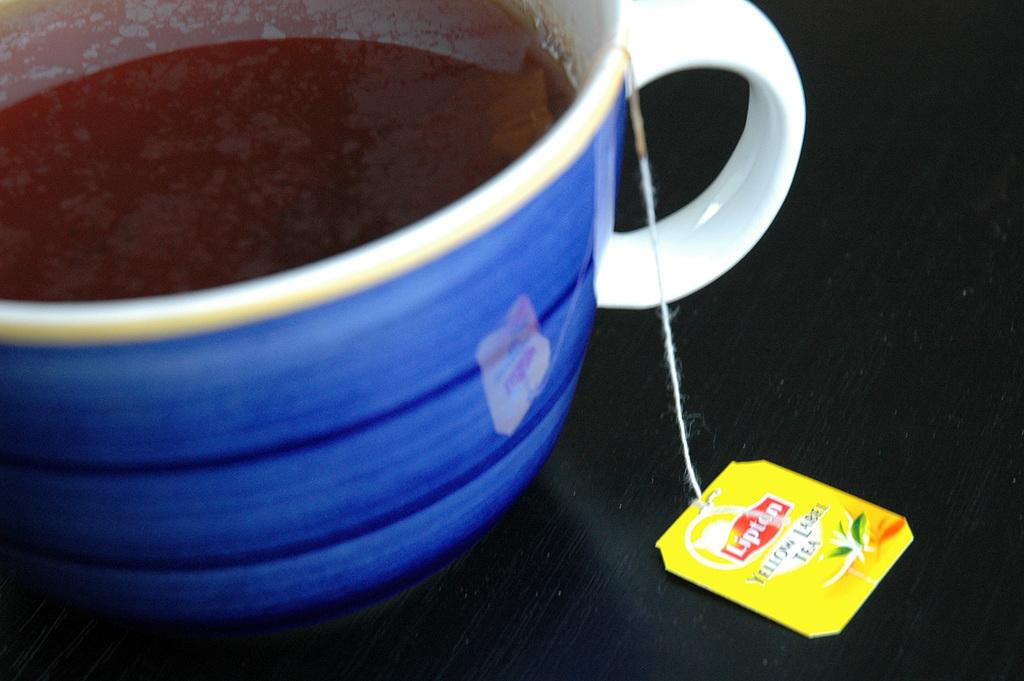What is in the cup that is visible in the image? There is a cup of tea in the image. Where is the cup of tea located in the image? The cup of tea is placed on a table. What type of title does the squirrel have in the image? There is no squirrel present in the image, so it cannot have a title. 